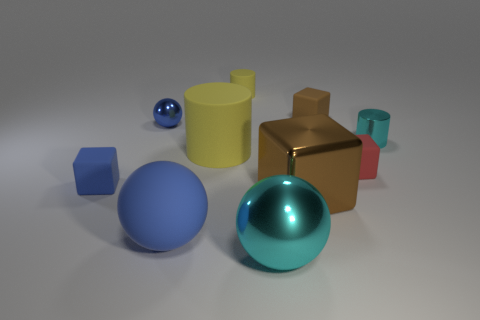What is the size of the cube that is both left of the brown matte object and right of the tiny blue matte block?
Offer a very short reply. Large. Is the big yellow cylinder made of the same material as the cyan object to the right of the small brown rubber block?
Your answer should be compact. No. What number of tiny brown things are the same shape as the tiny yellow object?
Keep it short and to the point. 0. There is another small block that is the same color as the metal block; what is its material?
Provide a short and direct response. Rubber. How many small blue shiny cylinders are there?
Give a very brief answer. 0. Does the tiny red matte object have the same shape as the brown thing that is behind the small metallic cylinder?
Give a very brief answer. Yes. How many objects are red matte cubes or cyan objects that are to the right of the metallic cube?
Your response must be concise. 2. There is a large object that is the same shape as the small red matte object; what is it made of?
Your response must be concise. Metal. There is a cyan metal object that is behind the cyan ball; does it have the same shape as the large yellow rubber object?
Your response must be concise. Yes. Are there fewer big brown things behind the red block than small spheres in front of the small blue metal ball?
Provide a short and direct response. No. 